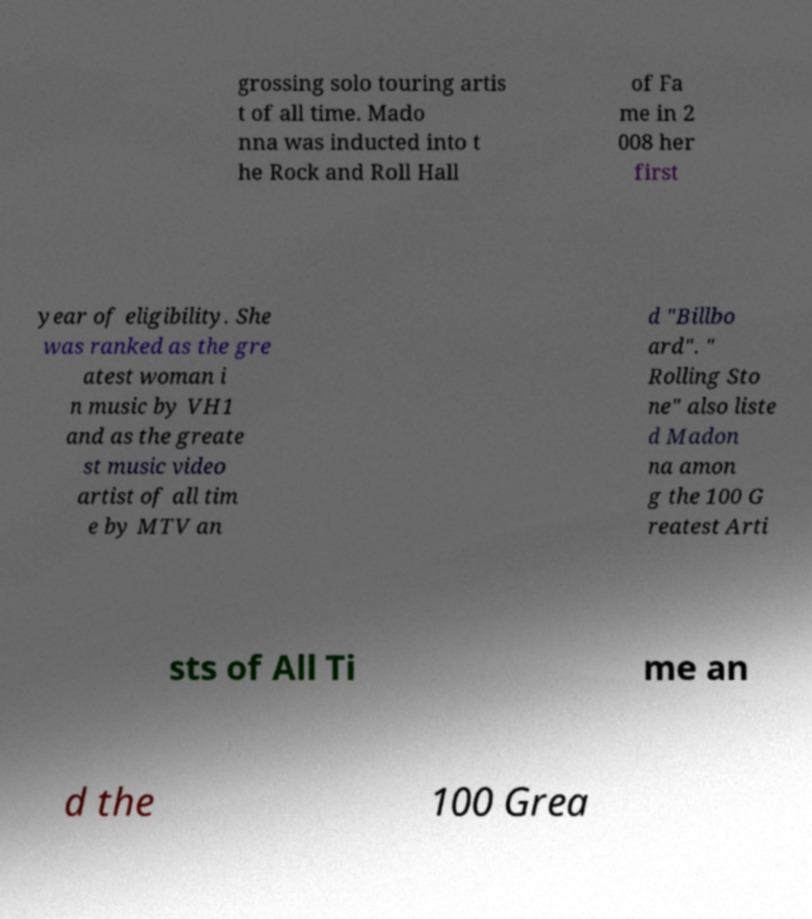For documentation purposes, I need the text within this image transcribed. Could you provide that? grossing solo touring artis t of all time. Mado nna was inducted into t he Rock and Roll Hall of Fa me in 2 008 her first year of eligibility. She was ranked as the gre atest woman i n music by VH1 and as the greate st music video artist of all tim e by MTV an d "Billbo ard". " Rolling Sto ne" also liste d Madon na amon g the 100 G reatest Arti sts of All Ti me an d the 100 Grea 